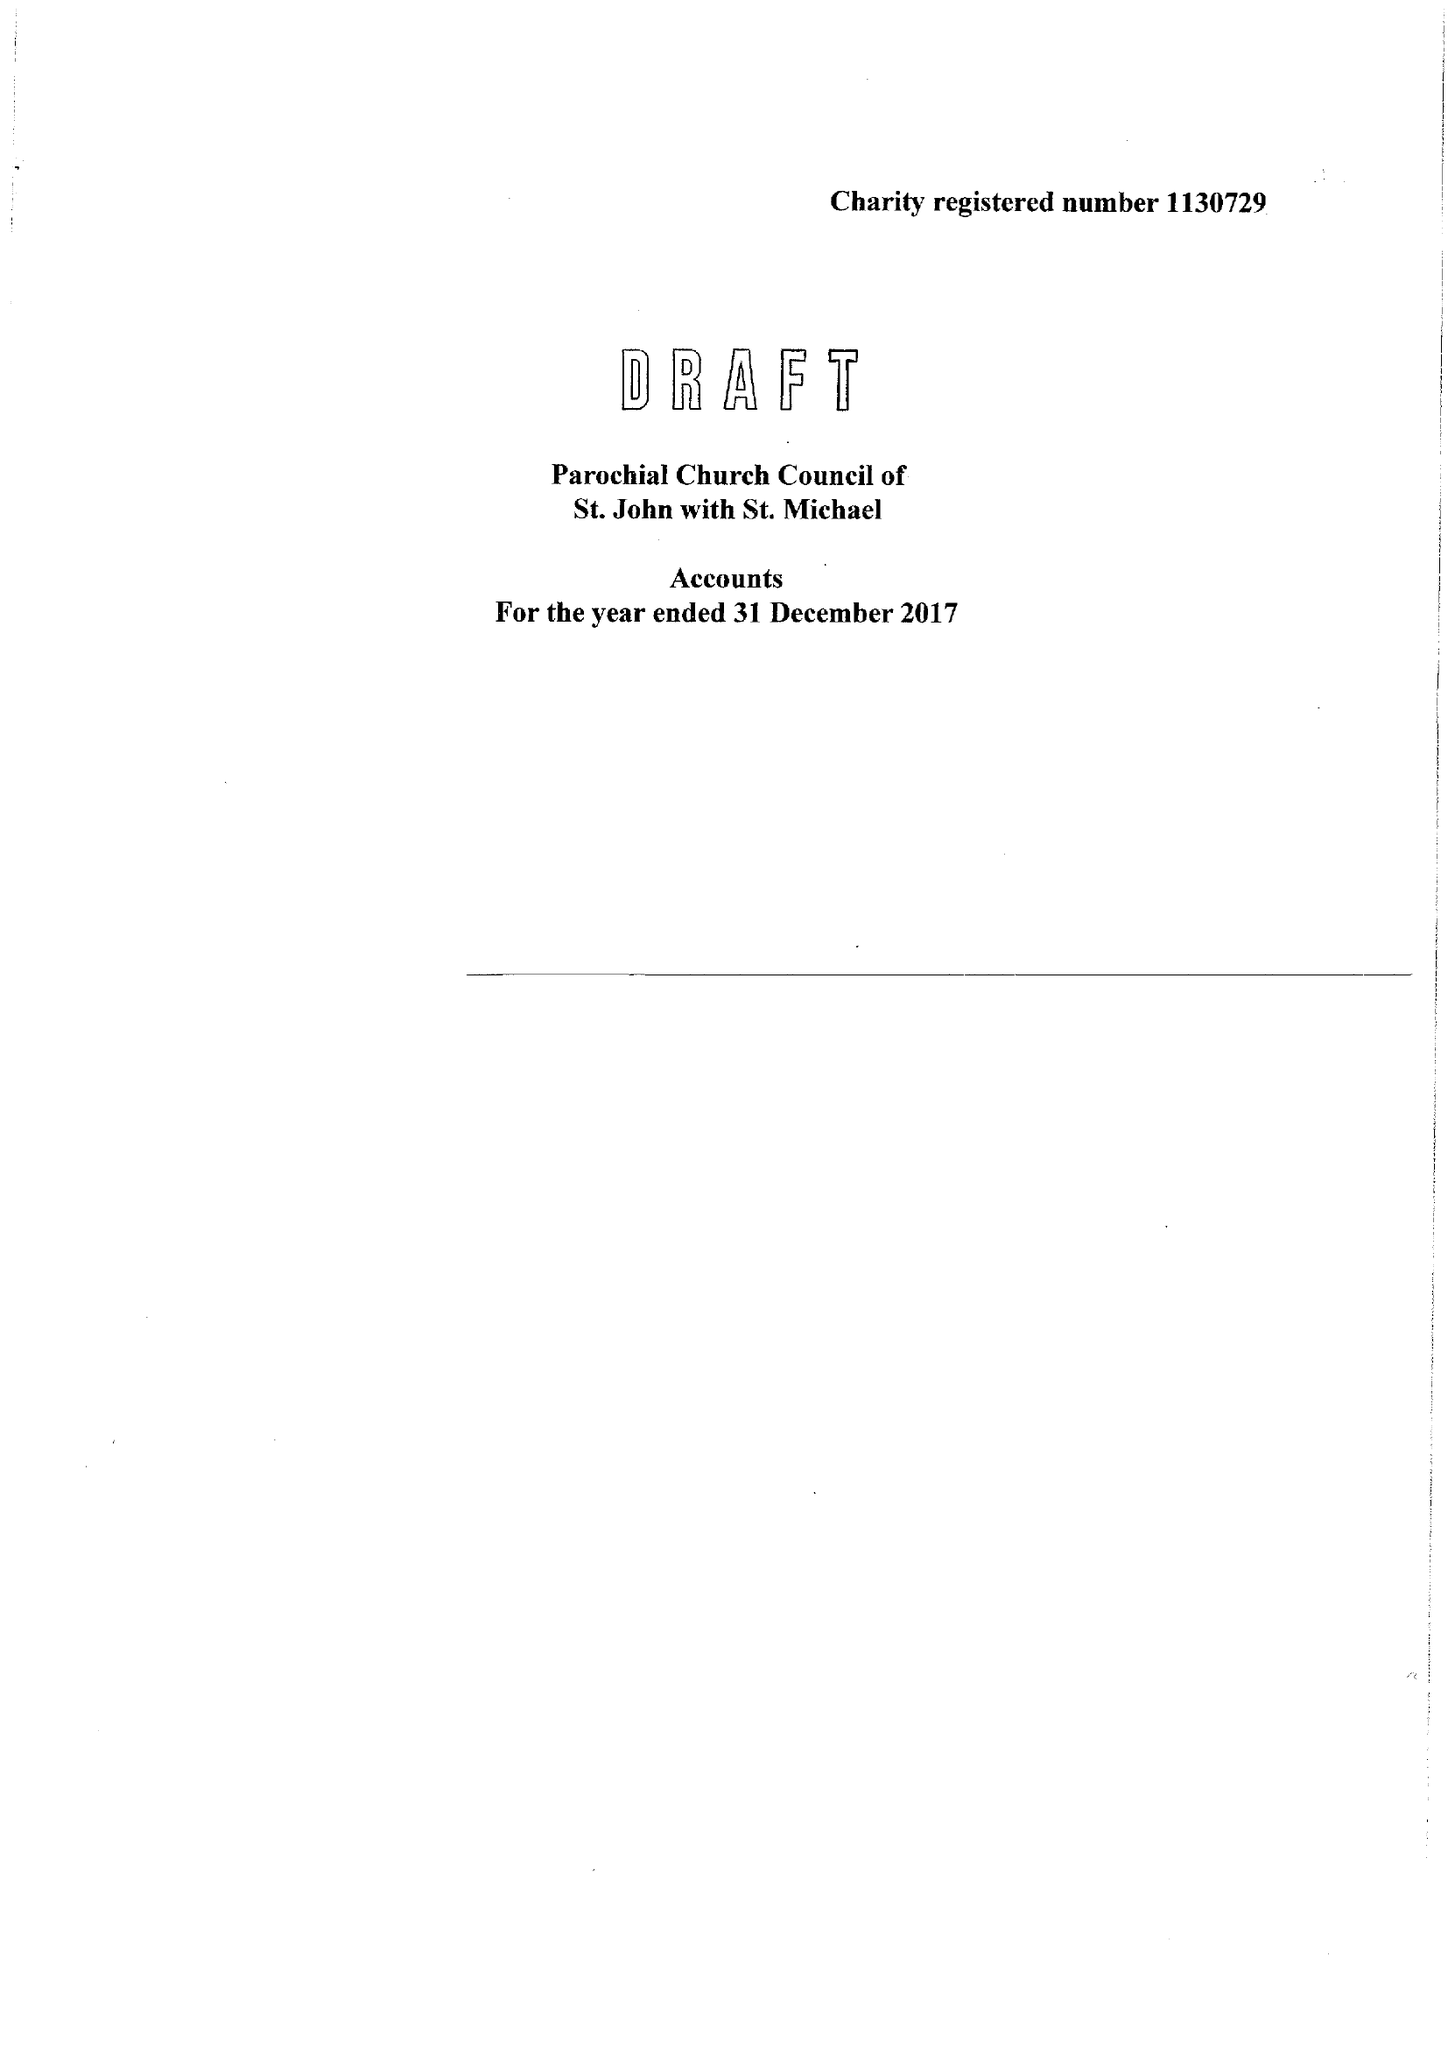What is the value for the income_annually_in_british_pounds?
Answer the question using a single word or phrase. 124335.00 